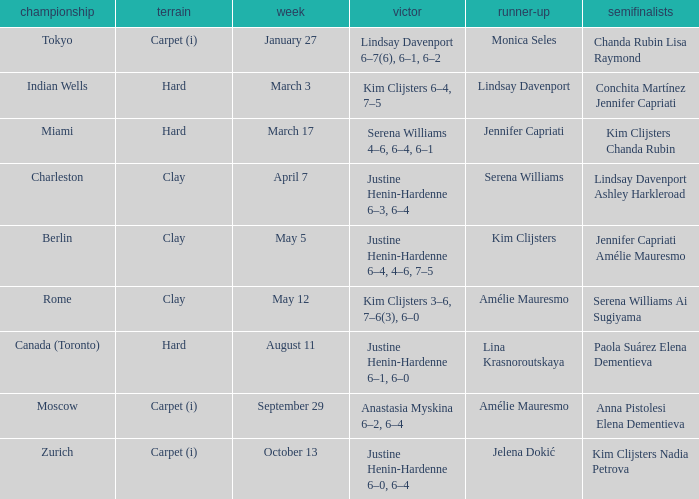Who was the winner against Lindsay Davenport? Kim Clijsters 6–4, 7–5. 